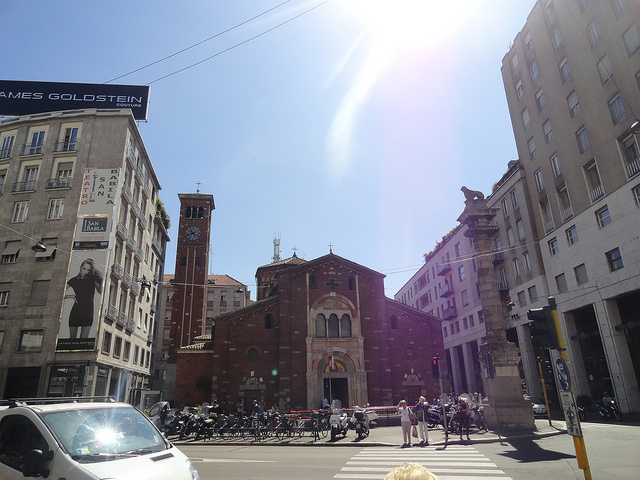What is the theater straight ahead? The building straight ahead is not a theater but the Basilica of San Lorenzo Maggiore, a notable historical church located in Milan, Italy, recognized for its significant architectural and cultural importance. 